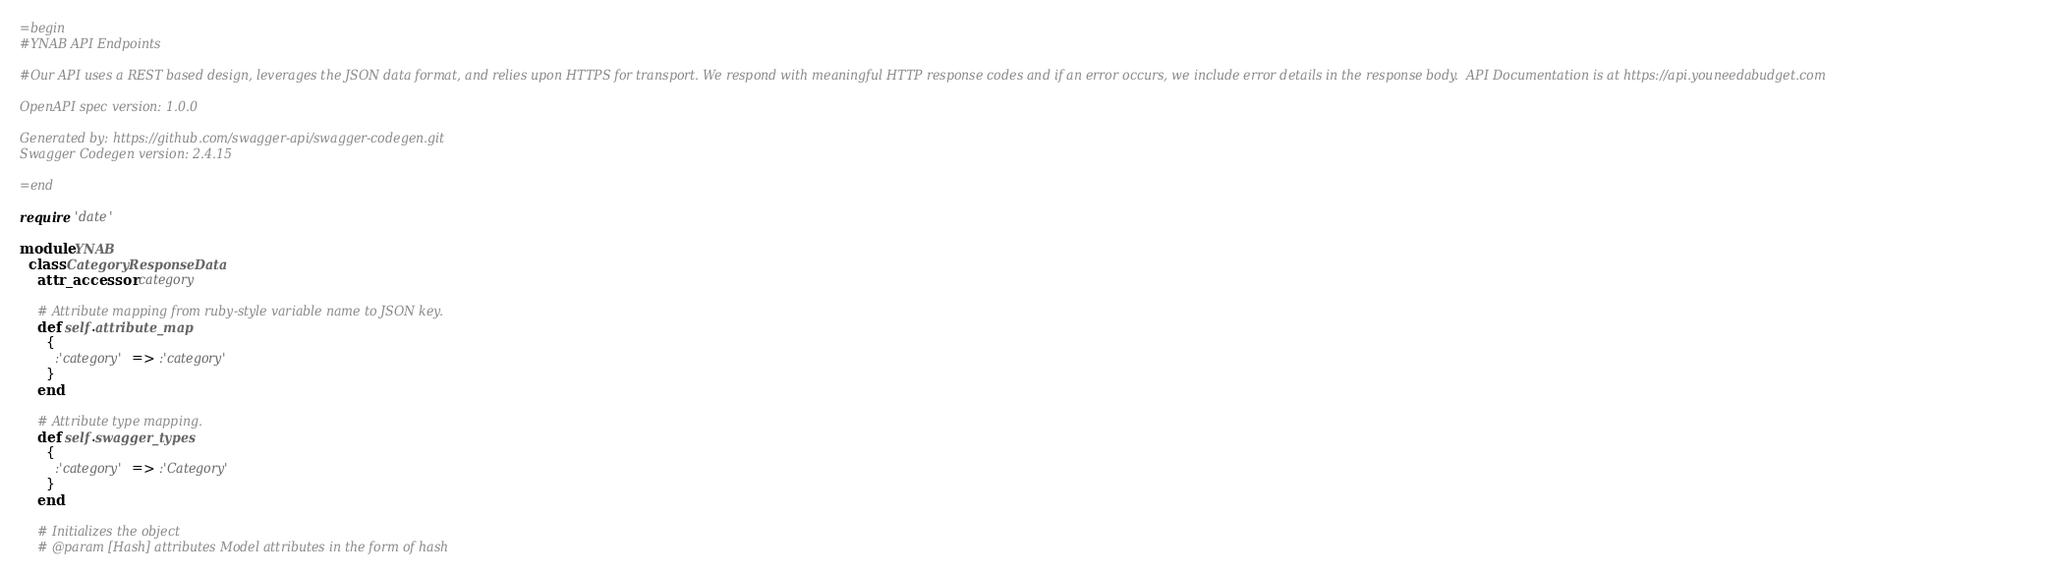<code> <loc_0><loc_0><loc_500><loc_500><_Ruby_>=begin
#YNAB API Endpoints

#Our API uses a REST based design, leverages the JSON data format, and relies upon HTTPS for transport. We respond with meaningful HTTP response codes and if an error occurs, we include error details in the response body.  API Documentation is at https://api.youneedabudget.com

OpenAPI spec version: 1.0.0

Generated by: https://github.com/swagger-api/swagger-codegen.git
Swagger Codegen version: 2.4.15

=end

require 'date'

module YNAB
  class CategoryResponseData
    attr_accessor :category

    # Attribute mapping from ruby-style variable name to JSON key.
    def self.attribute_map
      {
        :'category' => :'category'
      }
    end

    # Attribute type mapping.
    def self.swagger_types
      {
        :'category' => :'Category'
      }
    end

    # Initializes the object
    # @param [Hash] attributes Model attributes in the form of hash</code> 